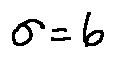Convert formula to latex. <formula><loc_0><loc_0><loc_500><loc_500>\sigma = 6</formula> 